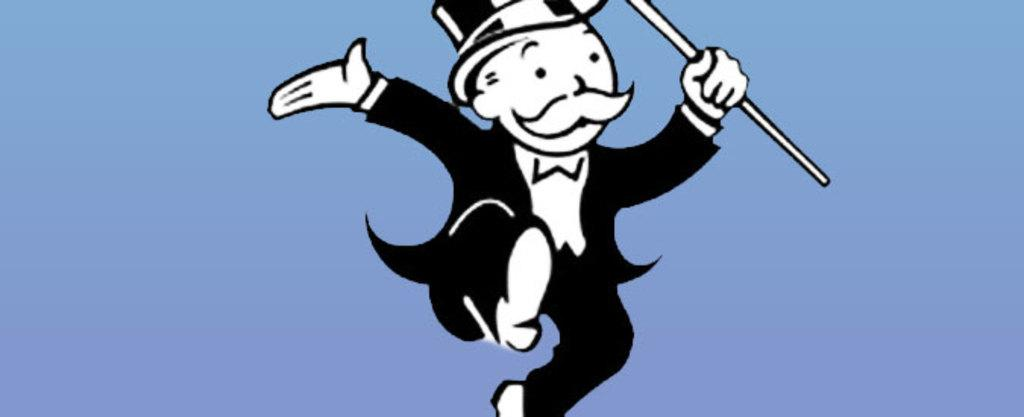Who is the main character in the image? The main character in the image is the Monopoly man. What is the Monopoly man holding in his hand? The Monopoly man is holding a stick in his hand. What color is the background of the image? The background color of the image is blue. How many planes can be seen in the image? There are no planes visible in the image. Is there a visitor in the image? The provided facts do not mention a visitor, so we cannot determine if there is one in the image. 